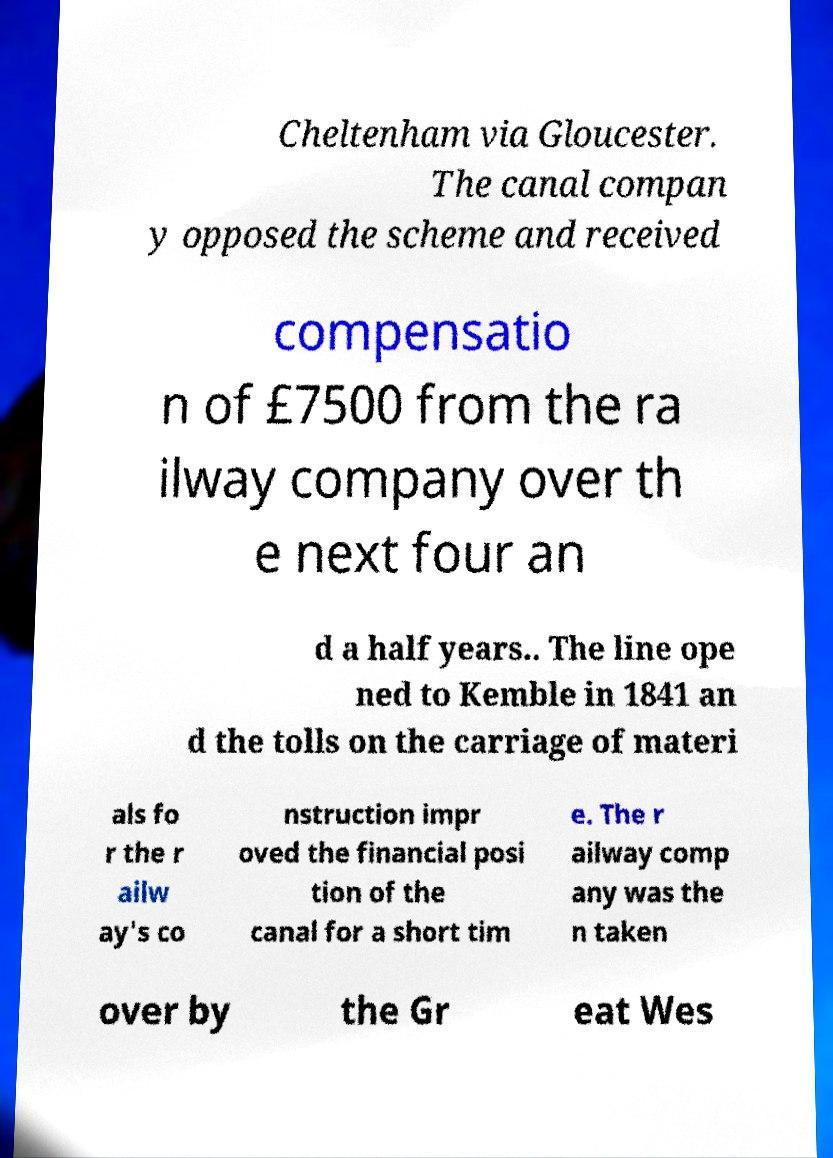Could you assist in decoding the text presented in this image and type it out clearly? Cheltenham via Gloucester. The canal compan y opposed the scheme and received compensatio n of £7500 from the ra ilway company over th e next four an d a half years.. The line ope ned to Kemble in 1841 an d the tolls on the carriage of materi als fo r the r ailw ay's co nstruction impr oved the financial posi tion of the canal for a short tim e. The r ailway comp any was the n taken over by the Gr eat Wes 